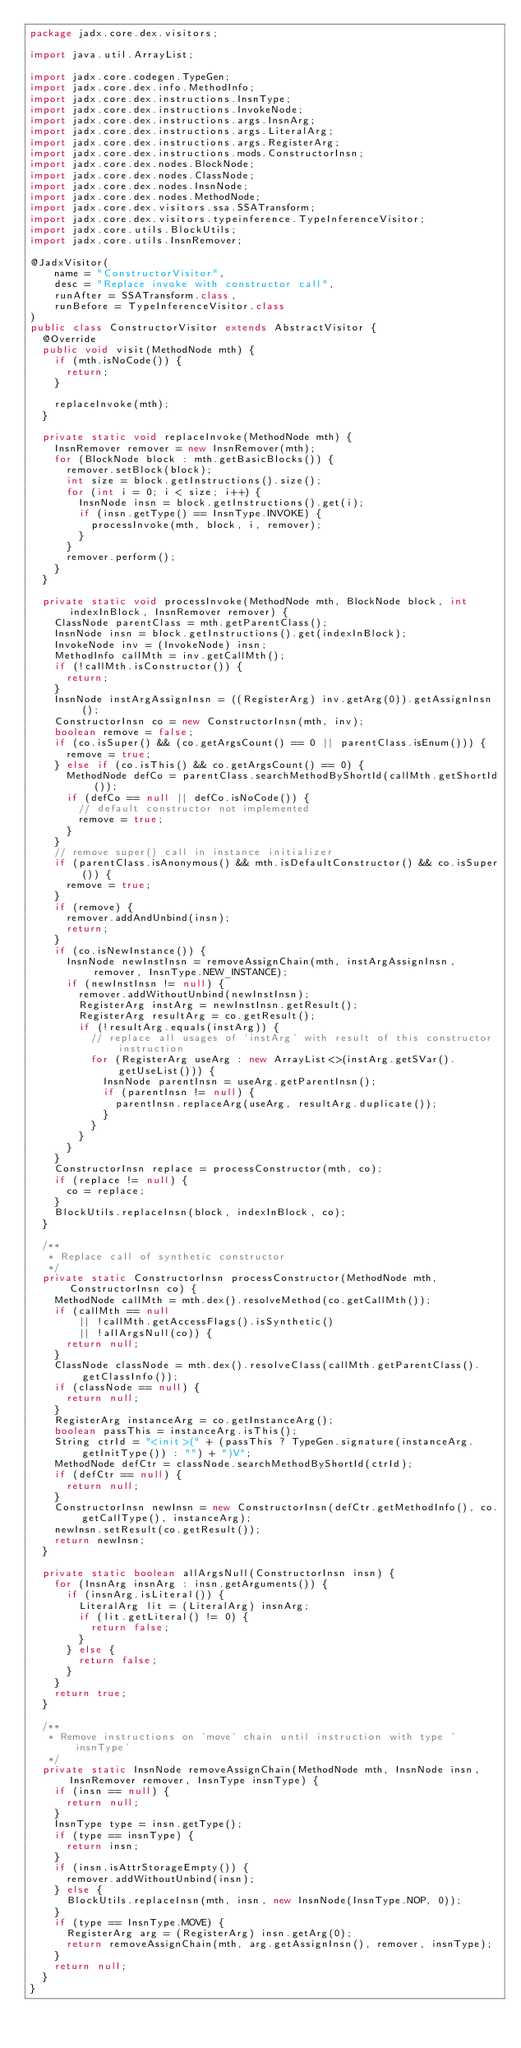Convert code to text. <code><loc_0><loc_0><loc_500><loc_500><_Java_>package jadx.core.dex.visitors;

import java.util.ArrayList;

import jadx.core.codegen.TypeGen;
import jadx.core.dex.info.MethodInfo;
import jadx.core.dex.instructions.InsnType;
import jadx.core.dex.instructions.InvokeNode;
import jadx.core.dex.instructions.args.InsnArg;
import jadx.core.dex.instructions.args.LiteralArg;
import jadx.core.dex.instructions.args.RegisterArg;
import jadx.core.dex.instructions.mods.ConstructorInsn;
import jadx.core.dex.nodes.BlockNode;
import jadx.core.dex.nodes.ClassNode;
import jadx.core.dex.nodes.InsnNode;
import jadx.core.dex.nodes.MethodNode;
import jadx.core.dex.visitors.ssa.SSATransform;
import jadx.core.dex.visitors.typeinference.TypeInferenceVisitor;
import jadx.core.utils.BlockUtils;
import jadx.core.utils.InsnRemover;

@JadxVisitor(
		name = "ConstructorVisitor",
		desc = "Replace invoke with constructor call",
		runAfter = SSATransform.class,
		runBefore = TypeInferenceVisitor.class
)
public class ConstructorVisitor extends AbstractVisitor {
	@Override
	public void visit(MethodNode mth) {
		if (mth.isNoCode()) {
			return;
		}

		replaceInvoke(mth);
	}

	private static void replaceInvoke(MethodNode mth) {
		InsnRemover remover = new InsnRemover(mth);
		for (BlockNode block : mth.getBasicBlocks()) {
			remover.setBlock(block);
			int size = block.getInstructions().size();
			for (int i = 0; i < size; i++) {
				InsnNode insn = block.getInstructions().get(i);
				if (insn.getType() == InsnType.INVOKE) {
					processInvoke(mth, block, i, remover);
				}
			}
			remover.perform();
		}
	}

	private static void processInvoke(MethodNode mth, BlockNode block, int indexInBlock, InsnRemover remover) {
		ClassNode parentClass = mth.getParentClass();
		InsnNode insn = block.getInstructions().get(indexInBlock);
		InvokeNode inv = (InvokeNode) insn;
		MethodInfo callMth = inv.getCallMth();
		if (!callMth.isConstructor()) {
			return;
		}
		InsnNode instArgAssignInsn = ((RegisterArg) inv.getArg(0)).getAssignInsn();
		ConstructorInsn co = new ConstructorInsn(mth, inv);
		boolean remove = false;
		if (co.isSuper() && (co.getArgsCount() == 0 || parentClass.isEnum())) {
			remove = true;
		} else if (co.isThis() && co.getArgsCount() == 0) {
			MethodNode defCo = parentClass.searchMethodByShortId(callMth.getShortId());
			if (defCo == null || defCo.isNoCode()) {
				// default constructor not implemented
				remove = true;
			}
		}
		// remove super() call in instance initializer
		if (parentClass.isAnonymous() && mth.isDefaultConstructor() && co.isSuper()) {
			remove = true;
		}
		if (remove) {
			remover.addAndUnbind(insn);
			return;
		}
		if (co.isNewInstance()) {
			InsnNode newInstInsn = removeAssignChain(mth, instArgAssignInsn, remover, InsnType.NEW_INSTANCE);
			if (newInstInsn != null) {
				remover.addWithoutUnbind(newInstInsn);
				RegisterArg instArg = newInstInsn.getResult();
				RegisterArg resultArg = co.getResult();
				if (!resultArg.equals(instArg)) {
					// replace all usages of 'instArg' with result of this constructor instruction
					for (RegisterArg useArg : new ArrayList<>(instArg.getSVar().getUseList())) {
						InsnNode parentInsn = useArg.getParentInsn();
						if (parentInsn != null) {
							parentInsn.replaceArg(useArg, resultArg.duplicate());
						}
					}
				}
			}
		}
		ConstructorInsn replace = processConstructor(mth, co);
		if (replace != null) {
			co = replace;
		}
		BlockUtils.replaceInsn(block, indexInBlock, co);
	}

	/**
	 * Replace call of synthetic constructor
	 */
	private static ConstructorInsn processConstructor(MethodNode mth, ConstructorInsn co) {
		MethodNode callMth = mth.dex().resolveMethod(co.getCallMth());
		if (callMth == null
				|| !callMth.getAccessFlags().isSynthetic()
				|| !allArgsNull(co)) {
			return null;
		}
		ClassNode classNode = mth.dex().resolveClass(callMth.getParentClass().getClassInfo());
		if (classNode == null) {
			return null;
		}
		RegisterArg instanceArg = co.getInstanceArg();
		boolean passThis = instanceArg.isThis();
		String ctrId = "<init>(" + (passThis ? TypeGen.signature(instanceArg.getInitType()) : "") + ")V";
		MethodNode defCtr = classNode.searchMethodByShortId(ctrId);
		if (defCtr == null) {
			return null;
		}
		ConstructorInsn newInsn = new ConstructorInsn(defCtr.getMethodInfo(), co.getCallType(), instanceArg);
		newInsn.setResult(co.getResult());
		return newInsn;
	}

	private static boolean allArgsNull(ConstructorInsn insn) {
		for (InsnArg insnArg : insn.getArguments()) {
			if (insnArg.isLiteral()) {
				LiteralArg lit = (LiteralArg) insnArg;
				if (lit.getLiteral() != 0) {
					return false;
				}
			} else {
				return false;
			}
		}
		return true;
	}

	/**
	 * Remove instructions on 'move' chain until instruction with type 'insnType'
	 */
	private static InsnNode removeAssignChain(MethodNode mth, InsnNode insn, InsnRemover remover, InsnType insnType) {
		if (insn == null) {
			return null;
		}
		InsnType type = insn.getType();
		if (type == insnType) {
			return insn;
		}
		if (insn.isAttrStorageEmpty()) {
			remover.addWithoutUnbind(insn);
		} else {
			BlockUtils.replaceInsn(mth, insn, new InsnNode(InsnType.NOP, 0));
		}
		if (type == InsnType.MOVE) {
			RegisterArg arg = (RegisterArg) insn.getArg(0);
			return removeAssignChain(mth, arg.getAssignInsn(), remover, insnType);
		}
		return null;
	}
}
</code> 